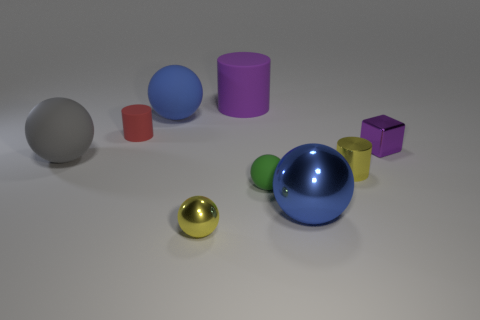Subtract all green spheres. How many spheres are left? 4 Subtract all large gray rubber spheres. How many spheres are left? 4 Subtract all cyan balls. Subtract all blue cylinders. How many balls are left? 5 Add 1 small red cylinders. How many objects exist? 10 Subtract all blocks. How many objects are left? 8 Subtract 0 gray cylinders. How many objects are left? 9 Subtract all big cyan rubber blocks. Subtract all rubber objects. How many objects are left? 4 Add 4 large shiny balls. How many large shiny balls are left? 5 Add 6 small purple cylinders. How many small purple cylinders exist? 6 